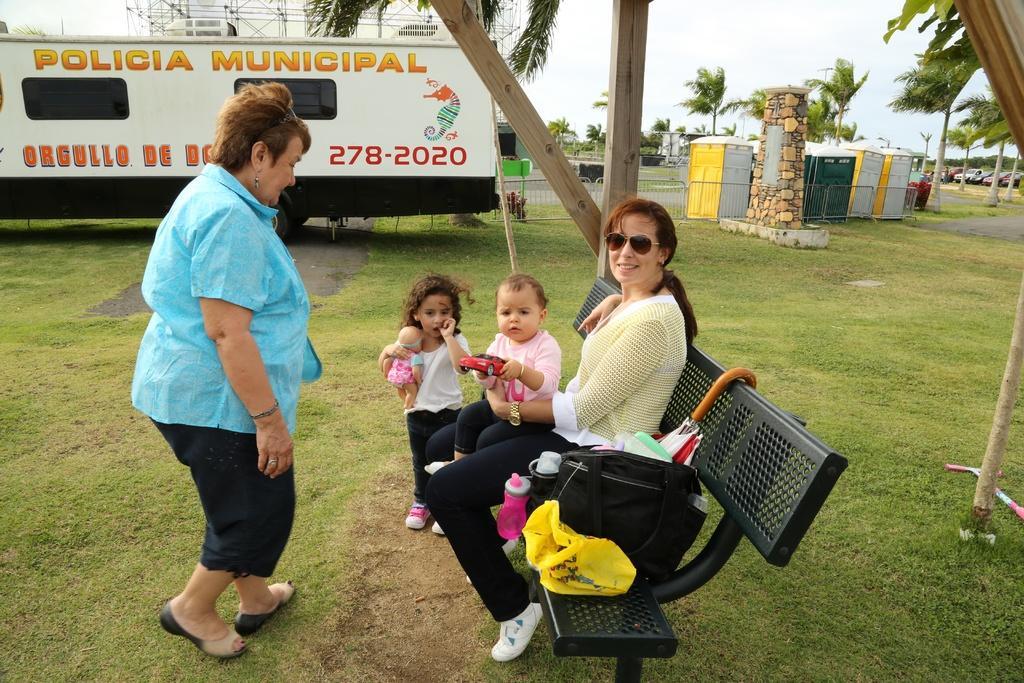In one or two sentences, can you explain what this image depicts? In the foreground of the image we can see a lady is sitting on the bench and holding a child and another lady is looking at the child. In the middle of the image we can see a bus and rocks. On the top of the image we can see the sky. 